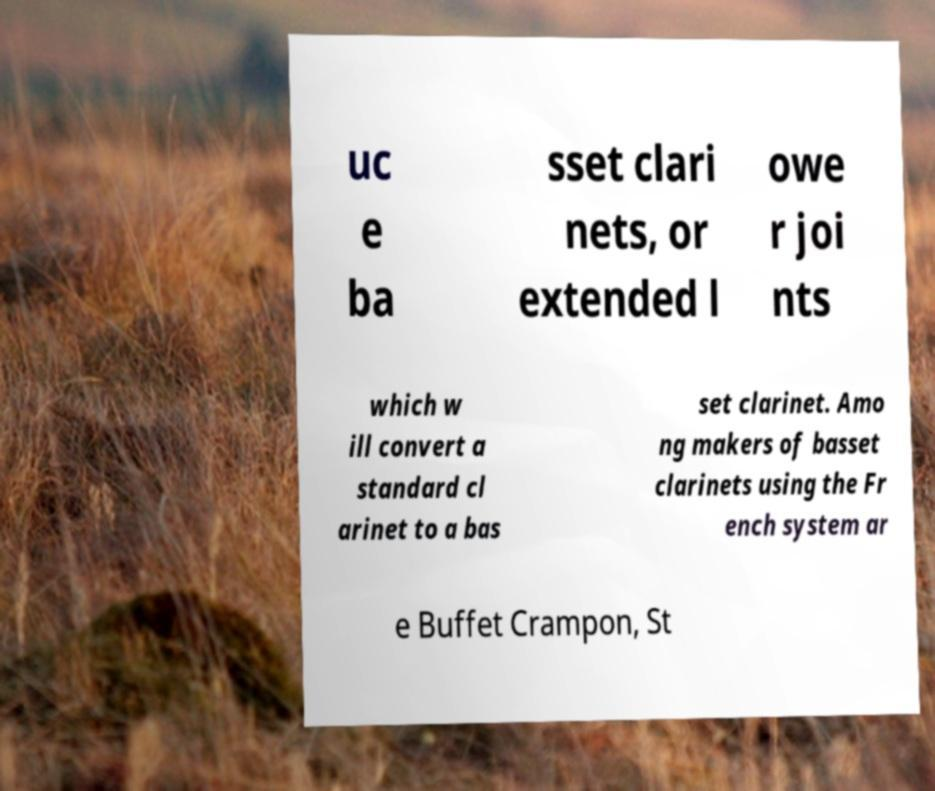Could you assist in decoding the text presented in this image and type it out clearly? uc e ba sset clari nets, or extended l owe r joi nts which w ill convert a standard cl arinet to a bas set clarinet. Amo ng makers of basset clarinets using the Fr ench system ar e Buffet Crampon, St 